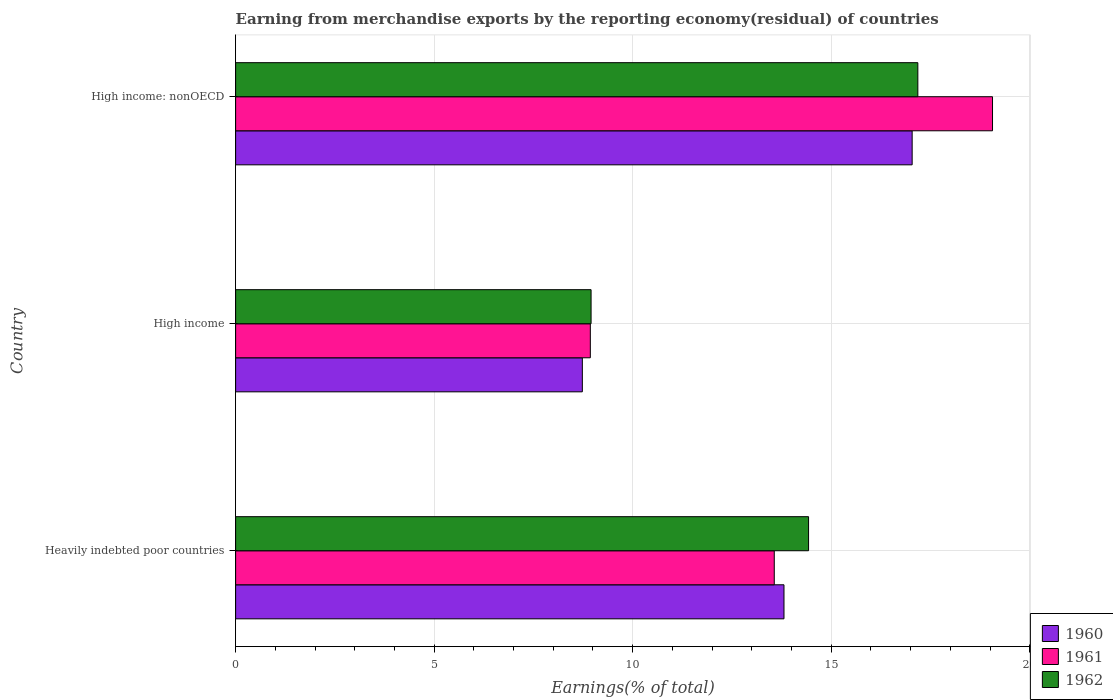How many different coloured bars are there?
Give a very brief answer. 3. Are the number of bars per tick equal to the number of legend labels?
Ensure brevity in your answer.  Yes. Are the number of bars on each tick of the Y-axis equal?
Your answer should be compact. Yes. How many bars are there on the 3rd tick from the top?
Offer a terse response. 3. How many bars are there on the 1st tick from the bottom?
Ensure brevity in your answer.  3. What is the label of the 3rd group of bars from the top?
Your answer should be very brief. Heavily indebted poor countries. In how many cases, is the number of bars for a given country not equal to the number of legend labels?
Give a very brief answer. 0. What is the percentage of amount earned from merchandise exports in 1962 in High income: nonOECD?
Provide a succinct answer. 17.18. Across all countries, what is the maximum percentage of amount earned from merchandise exports in 1961?
Your response must be concise. 19.06. Across all countries, what is the minimum percentage of amount earned from merchandise exports in 1960?
Offer a terse response. 8.73. In which country was the percentage of amount earned from merchandise exports in 1961 maximum?
Offer a terse response. High income: nonOECD. In which country was the percentage of amount earned from merchandise exports in 1961 minimum?
Keep it short and to the point. High income. What is the total percentage of amount earned from merchandise exports in 1961 in the graph?
Give a very brief answer. 41.56. What is the difference between the percentage of amount earned from merchandise exports in 1962 in High income and that in High income: nonOECD?
Make the answer very short. -8.23. What is the difference between the percentage of amount earned from merchandise exports in 1960 in Heavily indebted poor countries and the percentage of amount earned from merchandise exports in 1962 in High income: nonOECD?
Offer a terse response. -3.37. What is the average percentage of amount earned from merchandise exports in 1960 per country?
Ensure brevity in your answer.  13.19. What is the difference between the percentage of amount earned from merchandise exports in 1962 and percentage of amount earned from merchandise exports in 1960 in Heavily indebted poor countries?
Provide a succinct answer. 0.62. What is the ratio of the percentage of amount earned from merchandise exports in 1960 in High income to that in High income: nonOECD?
Offer a terse response. 0.51. What is the difference between the highest and the second highest percentage of amount earned from merchandise exports in 1961?
Your answer should be very brief. 5.5. What is the difference between the highest and the lowest percentage of amount earned from merchandise exports in 1962?
Give a very brief answer. 8.23. Is the sum of the percentage of amount earned from merchandise exports in 1961 in Heavily indebted poor countries and High income greater than the maximum percentage of amount earned from merchandise exports in 1960 across all countries?
Offer a terse response. Yes. What does the 2nd bar from the top in High income represents?
Offer a very short reply. 1961. What is the difference between two consecutive major ticks on the X-axis?
Provide a succinct answer. 5. Are the values on the major ticks of X-axis written in scientific E-notation?
Keep it short and to the point. No. Where does the legend appear in the graph?
Give a very brief answer. Bottom right. How many legend labels are there?
Offer a terse response. 3. How are the legend labels stacked?
Provide a succinct answer. Vertical. What is the title of the graph?
Your response must be concise. Earning from merchandise exports by the reporting economy(residual) of countries. Does "2000" appear as one of the legend labels in the graph?
Offer a very short reply. No. What is the label or title of the X-axis?
Give a very brief answer. Earnings(% of total). What is the label or title of the Y-axis?
Keep it short and to the point. Country. What is the Earnings(% of total) of 1960 in Heavily indebted poor countries?
Offer a terse response. 13.81. What is the Earnings(% of total) of 1961 in Heavily indebted poor countries?
Offer a terse response. 13.57. What is the Earnings(% of total) in 1962 in Heavily indebted poor countries?
Offer a very short reply. 14.43. What is the Earnings(% of total) in 1960 in High income?
Your answer should be very brief. 8.73. What is the Earnings(% of total) of 1961 in High income?
Your answer should be very brief. 8.93. What is the Earnings(% of total) of 1962 in High income?
Your response must be concise. 8.95. What is the Earnings(% of total) in 1960 in High income: nonOECD?
Make the answer very short. 17.04. What is the Earnings(% of total) in 1961 in High income: nonOECD?
Provide a succinct answer. 19.06. What is the Earnings(% of total) in 1962 in High income: nonOECD?
Provide a succinct answer. 17.18. Across all countries, what is the maximum Earnings(% of total) in 1960?
Your answer should be compact. 17.04. Across all countries, what is the maximum Earnings(% of total) in 1961?
Your response must be concise. 19.06. Across all countries, what is the maximum Earnings(% of total) in 1962?
Your response must be concise. 17.18. Across all countries, what is the minimum Earnings(% of total) of 1960?
Give a very brief answer. 8.73. Across all countries, what is the minimum Earnings(% of total) in 1961?
Provide a succinct answer. 8.93. Across all countries, what is the minimum Earnings(% of total) of 1962?
Give a very brief answer. 8.95. What is the total Earnings(% of total) of 1960 in the graph?
Your response must be concise. 39.58. What is the total Earnings(% of total) in 1961 in the graph?
Provide a succinct answer. 41.56. What is the total Earnings(% of total) of 1962 in the graph?
Your response must be concise. 40.57. What is the difference between the Earnings(% of total) in 1960 in Heavily indebted poor countries and that in High income?
Your answer should be very brief. 5.08. What is the difference between the Earnings(% of total) of 1961 in Heavily indebted poor countries and that in High income?
Your response must be concise. 4.63. What is the difference between the Earnings(% of total) in 1962 in Heavily indebted poor countries and that in High income?
Provide a short and direct response. 5.48. What is the difference between the Earnings(% of total) in 1960 in Heavily indebted poor countries and that in High income: nonOECD?
Your response must be concise. -3.23. What is the difference between the Earnings(% of total) of 1961 in Heavily indebted poor countries and that in High income: nonOECD?
Give a very brief answer. -5.5. What is the difference between the Earnings(% of total) in 1962 in Heavily indebted poor countries and that in High income: nonOECD?
Make the answer very short. -2.75. What is the difference between the Earnings(% of total) in 1960 in High income and that in High income: nonOECD?
Provide a succinct answer. -8.31. What is the difference between the Earnings(% of total) in 1961 in High income and that in High income: nonOECD?
Provide a succinct answer. -10.13. What is the difference between the Earnings(% of total) in 1962 in High income and that in High income: nonOECD?
Keep it short and to the point. -8.23. What is the difference between the Earnings(% of total) of 1960 in Heavily indebted poor countries and the Earnings(% of total) of 1961 in High income?
Make the answer very short. 4.88. What is the difference between the Earnings(% of total) of 1960 in Heavily indebted poor countries and the Earnings(% of total) of 1962 in High income?
Provide a short and direct response. 4.86. What is the difference between the Earnings(% of total) in 1961 in Heavily indebted poor countries and the Earnings(% of total) in 1962 in High income?
Ensure brevity in your answer.  4.61. What is the difference between the Earnings(% of total) in 1960 in Heavily indebted poor countries and the Earnings(% of total) in 1961 in High income: nonOECD?
Make the answer very short. -5.25. What is the difference between the Earnings(% of total) in 1960 in Heavily indebted poor countries and the Earnings(% of total) in 1962 in High income: nonOECD?
Offer a very short reply. -3.37. What is the difference between the Earnings(% of total) in 1961 in Heavily indebted poor countries and the Earnings(% of total) in 1962 in High income: nonOECD?
Make the answer very short. -3.62. What is the difference between the Earnings(% of total) in 1960 in High income and the Earnings(% of total) in 1961 in High income: nonOECD?
Your answer should be compact. -10.33. What is the difference between the Earnings(% of total) in 1960 in High income and the Earnings(% of total) in 1962 in High income: nonOECD?
Offer a very short reply. -8.45. What is the difference between the Earnings(% of total) in 1961 in High income and the Earnings(% of total) in 1962 in High income: nonOECD?
Your answer should be very brief. -8.25. What is the average Earnings(% of total) of 1960 per country?
Make the answer very short. 13.19. What is the average Earnings(% of total) in 1961 per country?
Keep it short and to the point. 13.85. What is the average Earnings(% of total) of 1962 per country?
Your answer should be very brief. 13.52. What is the difference between the Earnings(% of total) in 1960 and Earnings(% of total) in 1961 in Heavily indebted poor countries?
Provide a short and direct response. 0.24. What is the difference between the Earnings(% of total) of 1960 and Earnings(% of total) of 1962 in Heavily indebted poor countries?
Offer a terse response. -0.62. What is the difference between the Earnings(% of total) of 1961 and Earnings(% of total) of 1962 in Heavily indebted poor countries?
Give a very brief answer. -0.86. What is the difference between the Earnings(% of total) in 1960 and Earnings(% of total) in 1961 in High income?
Your answer should be compact. -0.2. What is the difference between the Earnings(% of total) of 1960 and Earnings(% of total) of 1962 in High income?
Ensure brevity in your answer.  -0.22. What is the difference between the Earnings(% of total) in 1961 and Earnings(% of total) in 1962 in High income?
Ensure brevity in your answer.  -0.02. What is the difference between the Earnings(% of total) in 1960 and Earnings(% of total) in 1961 in High income: nonOECD?
Keep it short and to the point. -2.02. What is the difference between the Earnings(% of total) in 1960 and Earnings(% of total) in 1962 in High income: nonOECD?
Make the answer very short. -0.14. What is the difference between the Earnings(% of total) in 1961 and Earnings(% of total) in 1962 in High income: nonOECD?
Provide a short and direct response. 1.88. What is the ratio of the Earnings(% of total) of 1960 in Heavily indebted poor countries to that in High income?
Your answer should be compact. 1.58. What is the ratio of the Earnings(% of total) of 1961 in Heavily indebted poor countries to that in High income?
Your answer should be very brief. 1.52. What is the ratio of the Earnings(% of total) in 1962 in Heavily indebted poor countries to that in High income?
Keep it short and to the point. 1.61. What is the ratio of the Earnings(% of total) of 1960 in Heavily indebted poor countries to that in High income: nonOECD?
Make the answer very short. 0.81. What is the ratio of the Earnings(% of total) of 1961 in Heavily indebted poor countries to that in High income: nonOECD?
Keep it short and to the point. 0.71. What is the ratio of the Earnings(% of total) of 1962 in Heavily indebted poor countries to that in High income: nonOECD?
Ensure brevity in your answer.  0.84. What is the ratio of the Earnings(% of total) of 1960 in High income to that in High income: nonOECD?
Make the answer very short. 0.51. What is the ratio of the Earnings(% of total) in 1961 in High income to that in High income: nonOECD?
Provide a short and direct response. 0.47. What is the ratio of the Earnings(% of total) of 1962 in High income to that in High income: nonOECD?
Offer a terse response. 0.52. What is the difference between the highest and the second highest Earnings(% of total) of 1960?
Provide a succinct answer. 3.23. What is the difference between the highest and the second highest Earnings(% of total) of 1961?
Your answer should be very brief. 5.5. What is the difference between the highest and the second highest Earnings(% of total) of 1962?
Your answer should be very brief. 2.75. What is the difference between the highest and the lowest Earnings(% of total) of 1960?
Give a very brief answer. 8.31. What is the difference between the highest and the lowest Earnings(% of total) of 1961?
Keep it short and to the point. 10.13. What is the difference between the highest and the lowest Earnings(% of total) in 1962?
Give a very brief answer. 8.23. 